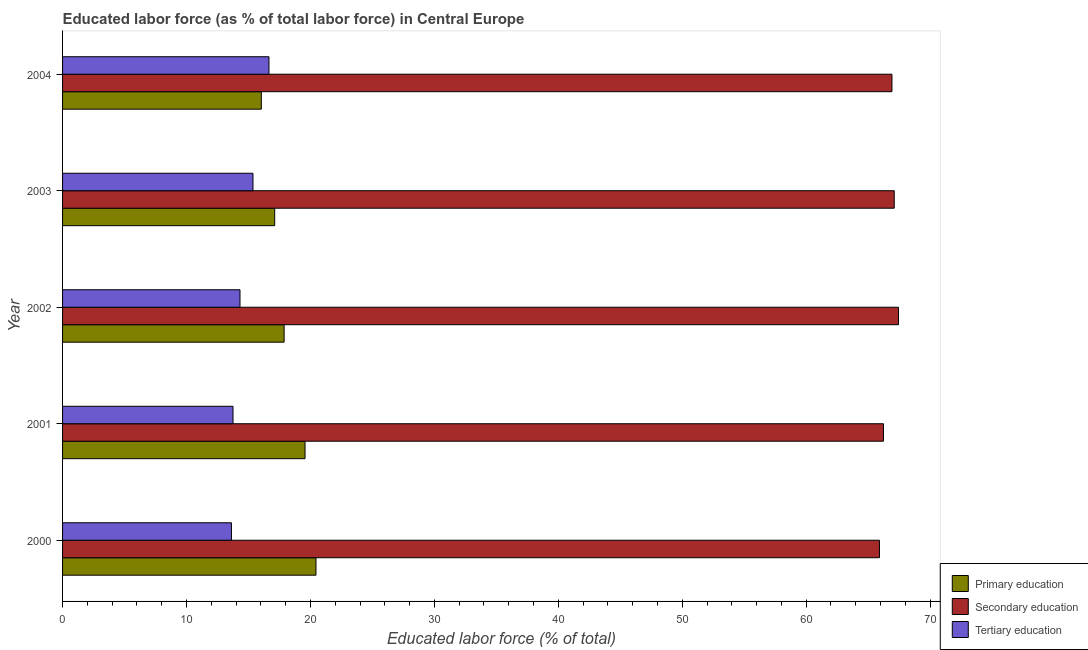How many different coloured bars are there?
Your response must be concise. 3. Are the number of bars on each tick of the Y-axis equal?
Give a very brief answer. Yes. How many bars are there on the 5th tick from the top?
Ensure brevity in your answer.  3. How many bars are there on the 4th tick from the bottom?
Your answer should be very brief. 3. What is the label of the 3rd group of bars from the top?
Your answer should be compact. 2002. In how many cases, is the number of bars for a given year not equal to the number of legend labels?
Offer a very short reply. 0. What is the percentage of labor force who received primary education in 2004?
Give a very brief answer. 16.04. Across all years, what is the maximum percentage of labor force who received tertiary education?
Ensure brevity in your answer.  16.65. Across all years, what is the minimum percentage of labor force who received secondary education?
Your answer should be compact. 65.91. In which year was the percentage of labor force who received tertiary education maximum?
Offer a very short reply. 2004. In which year was the percentage of labor force who received primary education minimum?
Offer a very short reply. 2004. What is the total percentage of labor force who received tertiary education in the graph?
Your answer should be very brief. 73.72. What is the difference between the percentage of labor force who received tertiary education in 2000 and that in 2001?
Provide a succinct answer. -0.13. What is the difference between the percentage of labor force who received secondary education in 2004 and the percentage of labor force who received primary education in 2000?
Make the answer very short. 46.48. What is the average percentage of labor force who received primary education per year?
Keep it short and to the point. 18.21. In the year 2002, what is the difference between the percentage of labor force who received primary education and percentage of labor force who received tertiary education?
Your answer should be compact. 3.56. What is the ratio of the percentage of labor force who received secondary education in 2000 to that in 2002?
Offer a terse response. 0.98. What is the difference between the highest and the second highest percentage of labor force who received primary education?
Give a very brief answer. 0.88. What is the difference between the highest and the lowest percentage of labor force who received tertiary education?
Offer a very short reply. 3.03. In how many years, is the percentage of labor force who received tertiary education greater than the average percentage of labor force who received tertiary education taken over all years?
Make the answer very short. 2. Is the sum of the percentage of labor force who received tertiary education in 2001 and 2004 greater than the maximum percentage of labor force who received secondary education across all years?
Offer a very short reply. No. What does the 2nd bar from the top in 2002 represents?
Your answer should be very brief. Secondary education. How many bars are there?
Your response must be concise. 15. Are all the bars in the graph horizontal?
Offer a terse response. Yes. What is the difference between two consecutive major ticks on the X-axis?
Provide a succinct answer. 10. Does the graph contain any zero values?
Provide a succinct answer. No. Where does the legend appear in the graph?
Your answer should be very brief. Bottom right. How many legend labels are there?
Give a very brief answer. 3. What is the title of the graph?
Provide a short and direct response. Educated labor force (as % of total labor force) in Central Europe. What is the label or title of the X-axis?
Offer a terse response. Educated labor force (% of total). What is the label or title of the Y-axis?
Ensure brevity in your answer.  Year. What is the Educated labor force (% of total) of Primary education in 2000?
Give a very brief answer. 20.45. What is the Educated labor force (% of total) of Secondary education in 2000?
Your response must be concise. 65.91. What is the Educated labor force (% of total) of Tertiary education in 2000?
Provide a succinct answer. 13.63. What is the Educated labor force (% of total) of Primary education in 2001?
Offer a very short reply. 19.56. What is the Educated labor force (% of total) in Secondary education in 2001?
Keep it short and to the point. 66.24. What is the Educated labor force (% of total) in Tertiary education in 2001?
Provide a short and direct response. 13.75. What is the Educated labor force (% of total) of Primary education in 2002?
Your answer should be very brief. 17.88. What is the Educated labor force (% of total) in Secondary education in 2002?
Make the answer very short. 67.45. What is the Educated labor force (% of total) in Tertiary education in 2002?
Your answer should be compact. 14.32. What is the Educated labor force (% of total) in Primary education in 2003?
Your response must be concise. 17.12. What is the Educated labor force (% of total) in Secondary education in 2003?
Give a very brief answer. 67.11. What is the Educated labor force (% of total) of Tertiary education in 2003?
Offer a terse response. 15.37. What is the Educated labor force (% of total) in Primary education in 2004?
Ensure brevity in your answer.  16.04. What is the Educated labor force (% of total) in Secondary education in 2004?
Ensure brevity in your answer.  66.92. What is the Educated labor force (% of total) in Tertiary education in 2004?
Make the answer very short. 16.65. Across all years, what is the maximum Educated labor force (% of total) of Primary education?
Provide a succinct answer. 20.45. Across all years, what is the maximum Educated labor force (% of total) in Secondary education?
Provide a succinct answer. 67.45. Across all years, what is the maximum Educated labor force (% of total) of Tertiary education?
Ensure brevity in your answer.  16.65. Across all years, what is the minimum Educated labor force (% of total) of Primary education?
Give a very brief answer. 16.04. Across all years, what is the minimum Educated labor force (% of total) of Secondary education?
Offer a very short reply. 65.91. Across all years, what is the minimum Educated labor force (% of total) in Tertiary education?
Keep it short and to the point. 13.63. What is the total Educated labor force (% of total) in Primary education in the graph?
Keep it short and to the point. 91.04. What is the total Educated labor force (% of total) of Secondary education in the graph?
Provide a short and direct response. 333.63. What is the total Educated labor force (% of total) in Tertiary education in the graph?
Ensure brevity in your answer.  73.72. What is the difference between the Educated labor force (% of total) of Primary education in 2000 and that in 2001?
Offer a terse response. 0.88. What is the difference between the Educated labor force (% of total) of Secondary education in 2000 and that in 2001?
Provide a short and direct response. -0.32. What is the difference between the Educated labor force (% of total) in Tertiary education in 2000 and that in 2001?
Make the answer very short. -0.13. What is the difference between the Educated labor force (% of total) of Primary education in 2000 and that in 2002?
Provide a succinct answer. 2.57. What is the difference between the Educated labor force (% of total) in Secondary education in 2000 and that in 2002?
Make the answer very short. -1.53. What is the difference between the Educated labor force (% of total) of Tertiary education in 2000 and that in 2002?
Your answer should be compact. -0.69. What is the difference between the Educated labor force (% of total) in Primary education in 2000 and that in 2003?
Make the answer very short. 3.33. What is the difference between the Educated labor force (% of total) in Secondary education in 2000 and that in 2003?
Provide a succinct answer. -1.19. What is the difference between the Educated labor force (% of total) in Tertiary education in 2000 and that in 2003?
Make the answer very short. -1.74. What is the difference between the Educated labor force (% of total) in Primary education in 2000 and that in 2004?
Your response must be concise. 4.41. What is the difference between the Educated labor force (% of total) of Secondary education in 2000 and that in 2004?
Your response must be concise. -1.01. What is the difference between the Educated labor force (% of total) in Tertiary education in 2000 and that in 2004?
Provide a short and direct response. -3.03. What is the difference between the Educated labor force (% of total) in Primary education in 2001 and that in 2002?
Your answer should be compact. 1.69. What is the difference between the Educated labor force (% of total) of Secondary education in 2001 and that in 2002?
Provide a succinct answer. -1.21. What is the difference between the Educated labor force (% of total) of Tertiary education in 2001 and that in 2002?
Provide a succinct answer. -0.56. What is the difference between the Educated labor force (% of total) of Primary education in 2001 and that in 2003?
Keep it short and to the point. 2.45. What is the difference between the Educated labor force (% of total) in Secondary education in 2001 and that in 2003?
Your answer should be compact. -0.87. What is the difference between the Educated labor force (% of total) of Tertiary education in 2001 and that in 2003?
Offer a very short reply. -1.61. What is the difference between the Educated labor force (% of total) of Primary education in 2001 and that in 2004?
Your response must be concise. 3.53. What is the difference between the Educated labor force (% of total) of Secondary education in 2001 and that in 2004?
Offer a terse response. -0.69. What is the difference between the Educated labor force (% of total) of Tertiary education in 2001 and that in 2004?
Offer a terse response. -2.9. What is the difference between the Educated labor force (% of total) in Primary education in 2002 and that in 2003?
Make the answer very short. 0.76. What is the difference between the Educated labor force (% of total) in Secondary education in 2002 and that in 2003?
Provide a short and direct response. 0.34. What is the difference between the Educated labor force (% of total) of Tertiary education in 2002 and that in 2003?
Keep it short and to the point. -1.05. What is the difference between the Educated labor force (% of total) of Primary education in 2002 and that in 2004?
Make the answer very short. 1.84. What is the difference between the Educated labor force (% of total) in Secondary education in 2002 and that in 2004?
Ensure brevity in your answer.  0.53. What is the difference between the Educated labor force (% of total) of Tertiary education in 2002 and that in 2004?
Your answer should be compact. -2.34. What is the difference between the Educated labor force (% of total) of Primary education in 2003 and that in 2004?
Keep it short and to the point. 1.08. What is the difference between the Educated labor force (% of total) in Secondary education in 2003 and that in 2004?
Ensure brevity in your answer.  0.18. What is the difference between the Educated labor force (% of total) of Tertiary education in 2003 and that in 2004?
Your answer should be very brief. -1.29. What is the difference between the Educated labor force (% of total) of Primary education in 2000 and the Educated labor force (% of total) of Secondary education in 2001?
Ensure brevity in your answer.  -45.79. What is the difference between the Educated labor force (% of total) of Primary education in 2000 and the Educated labor force (% of total) of Tertiary education in 2001?
Offer a very short reply. 6.69. What is the difference between the Educated labor force (% of total) in Secondary education in 2000 and the Educated labor force (% of total) in Tertiary education in 2001?
Your response must be concise. 52.16. What is the difference between the Educated labor force (% of total) of Primary education in 2000 and the Educated labor force (% of total) of Secondary education in 2002?
Give a very brief answer. -47. What is the difference between the Educated labor force (% of total) of Primary education in 2000 and the Educated labor force (% of total) of Tertiary education in 2002?
Keep it short and to the point. 6.13. What is the difference between the Educated labor force (% of total) in Secondary education in 2000 and the Educated labor force (% of total) in Tertiary education in 2002?
Ensure brevity in your answer.  51.6. What is the difference between the Educated labor force (% of total) in Primary education in 2000 and the Educated labor force (% of total) in Secondary education in 2003?
Keep it short and to the point. -46.66. What is the difference between the Educated labor force (% of total) of Primary education in 2000 and the Educated labor force (% of total) of Tertiary education in 2003?
Offer a terse response. 5.08. What is the difference between the Educated labor force (% of total) in Secondary education in 2000 and the Educated labor force (% of total) in Tertiary education in 2003?
Make the answer very short. 50.55. What is the difference between the Educated labor force (% of total) of Primary education in 2000 and the Educated labor force (% of total) of Secondary education in 2004?
Your answer should be compact. -46.48. What is the difference between the Educated labor force (% of total) of Primary education in 2000 and the Educated labor force (% of total) of Tertiary education in 2004?
Your response must be concise. 3.79. What is the difference between the Educated labor force (% of total) in Secondary education in 2000 and the Educated labor force (% of total) in Tertiary education in 2004?
Keep it short and to the point. 49.26. What is the difference between the Educated labor force (% of total) in Primary education in 2001 and the Educated labor force (% of total) in Secondary education in 2002?
Your response must be concise. -47.89. What is the difference between the Educated labor force (% of total) of Primary education in 2001 and the Educated labor force (% of total) of Tertiary education in 2002?
Provide a short and direct response. 5.25. What is the difference between the Educated labor force (% of total) of Secondary education in 2001 and the Educated labor force (% of total) of Tertiary education in 2002?
Keep it short and to the point. 51.92. What is the difference between the Educated labor force (% of total) in Primary education in 2001 and the Educated labor force (% of total) in Secondary education in 2003?
Offer a terse response. -47.54. What is the difference between the Educated labor force (% of total) of Primary education in 2001 and the Educated labor force (% of total) of Tertiary education in 2003?
Your answer should be compact. 4.2. What is the difference between the Educated labor force (% of total) of Secondary education in 2001 and the Educated labor force (% of total) of Tertiary education in 2003?
Ensure brevity in your answer.  50.87. What is the difference between the Educated labor force (% of total) of Primary education in 2001 and the Educated labor force (% of total) of Secondary education in 2004?
Keep it short and to the point. -47.36. What is the difference between the Educated labor force (% of total) in Primary education in 2001 and the Educated labor force (% of total) in Tertiary education in 2004?
Give a very brief answer. 2.91. What is the difference between the Educated labor force (% of total) in Secondary education in 2001 and the Educated labor force (% of total) in Tertiary education in 2004?
Your response must be concise. 49.58. What is the difference between the Educated labor force (% of total) of Primary education in 2002 and the Educated labor force (% of total) of Secondary education in 2003?
Give a very brief answer. -49.23. What is the difference between the Educated labor force (% of total) of Primary education in 2002 and the Educated labor force (% of total) of Tertiary education in 2003?
Provide a succinct answer. 2.51. What is the difference between the Educated labor force (% of total) of Secondary education in 2002 and the Educated labor force (% of total) of Tertiary education in 2003?
Offer a very short reply. 52.08. What is the difference between the Educated labor force (% of total) of Primary education in 2002 and the Educated labor force (% of total) of Secondary education in 2004?
Keep it short and to the point. -49.05. What is the difference between the Educated labor force (% of total) in Primary education in 2002 and the Educated labor force (% of total) in Tertiary education in 2004?
Ensure brevity in your answer.  1.22. What is the difference between the Educated labor force (% of total) in Secondary education in 2002 and the Educated labor force (% of total) in Tertiary education in 2004?
Ensure brevity in your answer.  50.8. What is the difference between the Educated labor force (% of total) in Primary education in 2003 and the Educated labor force (% of total) in Secondary education in 2004?
Give a very brief answer. -49.81. What is the difference between the Educated labor force (% of total) of Primary education in 2003 and the Educated labor force (% of total) of Tertiary education in 2004?
Provide a succinct answer. 0.46. What is the difference between the Educated labor force (% of total) of Secondary education in 2003 and the Educated labor force (% of total) of Tertiary education in 2004?
Offer a very short reply. 50.45. What is the average Educated labor force (% of total) of Primary education per year?
Keep it short and to the point. 18.21. What is the average Educated labor force (% of total) in Secondary education per year?
Offer a very short reply. 66.73. What is the average Educated labor force (% of total) of Tertiary education per year?
Make the answer very short. 14.74. In the year 2000, what is the difference between the Educated labor force (% of total) of Primary education and Educated labor force (% of total) of Secondary education?
Ensure brevity in your answer.  -45.47. In the year 2000, what is the difference between the Educated labor force (% of total) in Primary education and Educated labor force (% of total) in Tertiary education?
Keep it short and to the point. 6.82. In the year 2000, what is the difference between the Educated labor force (% of total) of Secondary education and Educated labor force (% of total) of Tertiary education?
Give a very brief answer. 52.29. In the year 2001, what is the difference between the Educated labor force (% of total) of Primary education and Educated labor force (% of total) of Secondary education?
Make the answer very short. -46.67. In the year 2001, what is the difference between the Educated labor force (% of total) of Primary education and Educated labor force (% of total) of Tertiary education?
Provide a short and direct response. 5.81. In the year 2001, what is the difference between the Educated labor force (% of total) of Secondary education and Educated labor force (% of total) of Tertiary education?
Your response must be concise. 52.48. In the year 2002, what is the difference between the Educated labor force (% of total) of Primary education and Educated labor force (% of total) of Secondary education?
Provide a succinct answer. -49.57. In the year 2002, what is the difference between the Educated labor force (% of total) in Primary education and Educated labor force (% of total) in Tertiary education?
Offer a very short reply. 3.56. In the year 2002, what is the difference between the Educated labor force (% of total) in Secondary education and Educated labor force (% of total) in Tertiary education?
Provide a short and direct response. 53.13. In the year 2003, what is the difference between the Educated labor force (% of total) in Primary education and Educated labor force (% of total) in Secondary education?
Your answer should be compact. -49.99. In the year 2003, what is the difference between the Educated labor force (% of total) in Primary education and Educated labor force (% of total) in Tertiary education?
Your answer should be compact. 1.75. In the year 2003, what is the difference between the Educated labor force (% of total) of Secondary education and Educated labor force (% of total) of Tertiary education?
Your answer should be very brief. 51.74. In the year 2004, what is the difference between the Educated labor force (% of total) in Primary education and Educated labor force (% of total) in Secondary education?
Make the answer very short. -50.89. In the year 2004, what is the difference between the Educated labor force (% of total) of Primary education and Educated labor force (% of total) of Tertiary education?
Your answer should be compact. -0.62. In the year 2004, what is the difference between the Educated labor force (% of total) in Secondary education and Educated labor force (% of total) in Tertiary education?
Keep it short and to the point. 50.27. What is the ratio of the Educated labor force (% of total) of Primary education in 2000 to that in 2001?
Your answer should be compact. 1.05. What is the ratio of the Educated labor force (% of total) of Secondary education in 2000 to that in 2001?
Provide a short and direct response. 1. What is the ratio of the Educated labor force (% of total) of Tertiary education in 2000 to that in 2001?
Give a very brief answer. 0.99. What is the ratio of the Educated labor force (% of total) of Primary education in 2000 to that in 2002?
Your answer should be very brief. 1.14. What is the ratio of the Educated labor force (% of total) in Secondary education in 2000 to that in 2002?
Give a very brief answer. 0.98. What is the ratio of the Educated labor force (% of total) in Tertiary education in 2000 to that in 2002?
Your response must be concise. 0.95. What is the ratio of the Educated labor force (% of total) in Primary education in 2000 to that in 2003?
Provide a succinct answer. 1.19. What is the ratio of the Educated labor force (% of total) of Secondary education in 2000 to that in 2003?
Offer a very short reply. 0.98. What is the ratio of the Educated labor force (% of total) in Tertiary education in 2000 to that in 2003?
Make the answer very short. 0.89. What is the ratio of the Educated labor force (% of total) in Primary education in 2000 to that in 2004?
Provide a short and direct response. 1.27. What is the ratio of the Educated labor force (% of total) in Secondary education in 2000 to that in 2004?
Offer a very short reply. 0.98. What is the ratio of the Educated labor force (% of total) of Tertiary education in 2000 to that in 2004?
Offer a terse response. 0.82. What is the ratio of the Educated labor force (% of total) of Primary education in 2001 to that in 2002?
Provide a succinct answer. 1.09. What is the ratio of the Educated labor force (% of total) of Tertiary education in 2001 to that in 2002?
Your response must be concise. 0.96. What is the ratio of the Educated labor force (% of total) of Primary education in 2001 to that in 2003?
Your answer should be compact. 1.14. What is the ratio of the Educated labor force (% of total) of Secondary education in 2001 to that in 2003?
Keep it short and to the point. 0.99. What is the ratio of the Educated labor force (% of total) in Tertiary education in 2001 to that in 2003?
Give a very brief answer. 0.9. What is the ratio of the Educated labor force (% of total) of Primary education in 2001 to that in 2004?
Make the answer very short. 1.22. What is the ratio of the Educated labor force (% of total) of Tertiary education in 2001 to that in 2004?
Make the answer very short. 0.83. What is the ratio of the Educated labor force (% of total) of Primary education in 2002 to that in 2003?
Your answer should be very brief. 1.04. What is the ratio of the Educated labor force (% of total) in Secondary education in 2002 to that in 2003?
Provide a succinct answer. 1.01. What is the ratio of the Educated labor force (% of total) in Tertiary education in 2002 to that in 2003?
Offer a terse response. 0.93. What is the ratio of the Educated labor force (% of total) in Primary education in 2002 to that in 2004?
Make the answer very short. 1.11. What is the ratio of the Educated labor force (% of total) of Secondary education in 2002 to that in 2004?
Ensure brevity in your answer.  1.01. What is the ratio of the Educated labor force (% of total) in Tertiary education in 2002 to that in 2004?
Offer a very short reply. 0.86. What is the ratio of the Educated labor force (% of total) of Primary education in 2003 to that in 2004?
Provide a short and direct response. 1.07. What is the ratio of the Educated labor force (% of total) in Secondary education in 2003 to that in 2004?
Provide a succinct answer. 1. What is the ratio of the Educated labor force (% of total) of Tertiary education in 2003 to that in 2004?
Provide a short and direct response. 0.92. What is the difference between the highest and the second highest Educated labor force (% of total) of Primary education?
Your answer should be compact. 0.88. What is the difference between the highest and the second highest Educated labor force (% of total) of Secondary education?
Your answer should be very brief. 0.34. What is the difference between the highest and the second highest Educated labor force (% of total) of Tertiary education?
Keep it short and to the point. 1.29. What is the difference between the highest and the lowest Educated labor force (% of total) of Primary education?
Make the answer very short. 4.41. What is the difference between the highest and the lowest Educated labor force (% of total) of Secondary education?
Offer a very short reply. 1.53. What is the difference between the highest and the lowest Educated labor force (% of total) in Tertiary education?
Offer a terse response. 3.03. 